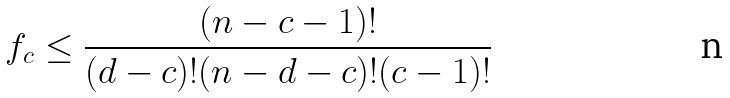<formula> <loc_0><loc_0><loc_500><loc_500>f _ { c } \leq \frac { ( n - c - 1 ) ! } { ( d - c ) ! ( n - d - c ) ! ( c - 1 ) ! }</formula> 